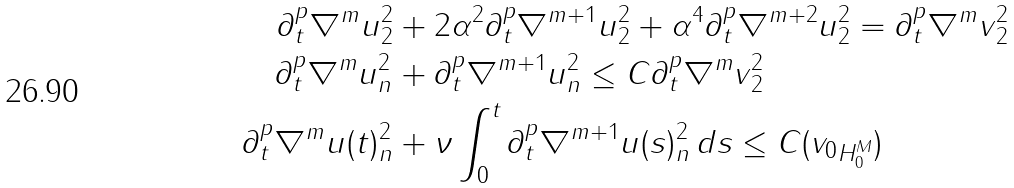Convert formula to latex. <formula><loc_0><loc_0><loc_500><loc_500>\| \partial ^ { p } _ { t } \nabla ^ { m } u \| _ { 2 } ^ { 2 } & + 2 \alpha ^ { 2 } \| \partial ^ { p } _ { t } \nabla ^ { m + 1 } u \| _ { 2 } ^ { 2 } + \alpha ^ { 4 } \| \partial ^ { p } _ { t } \nabla ^ { m + 2 } u \| _ { 2 } ^ { 2 } = \| \partial ^ { p } _ { t } \nabla ^ { m } v \| _ { 2 } ^ { 2 } \\ \| \partial ^ { p } _ { t } \nabla ^ { m } u \| _ { n } ^ { 2 } & + \| \partial ^ { p } _ { t } \nabla ^ { m + 1 } u \| _ { n } ^ { 2 } \leq C \| \partial ^ { p } _ { t } \nabla ^ { m } v \| ^ { 2 } _ { 2 } \\ \| \partial ^ { p } _ { t } \nabla ^ { m } u ( t ) \| _ { n } ^ { 2 } & + \nu \int _ { 0 } ^ { t } \| \partial _ { t } ^ { p } \nabla ^ { m + 1 } u ( s ) \| _ { n } ^ { 2 } \, d s \leq C ( \| v _ { 0 } \| _ { H ^ { M } _ { 0 } } )</formula> 